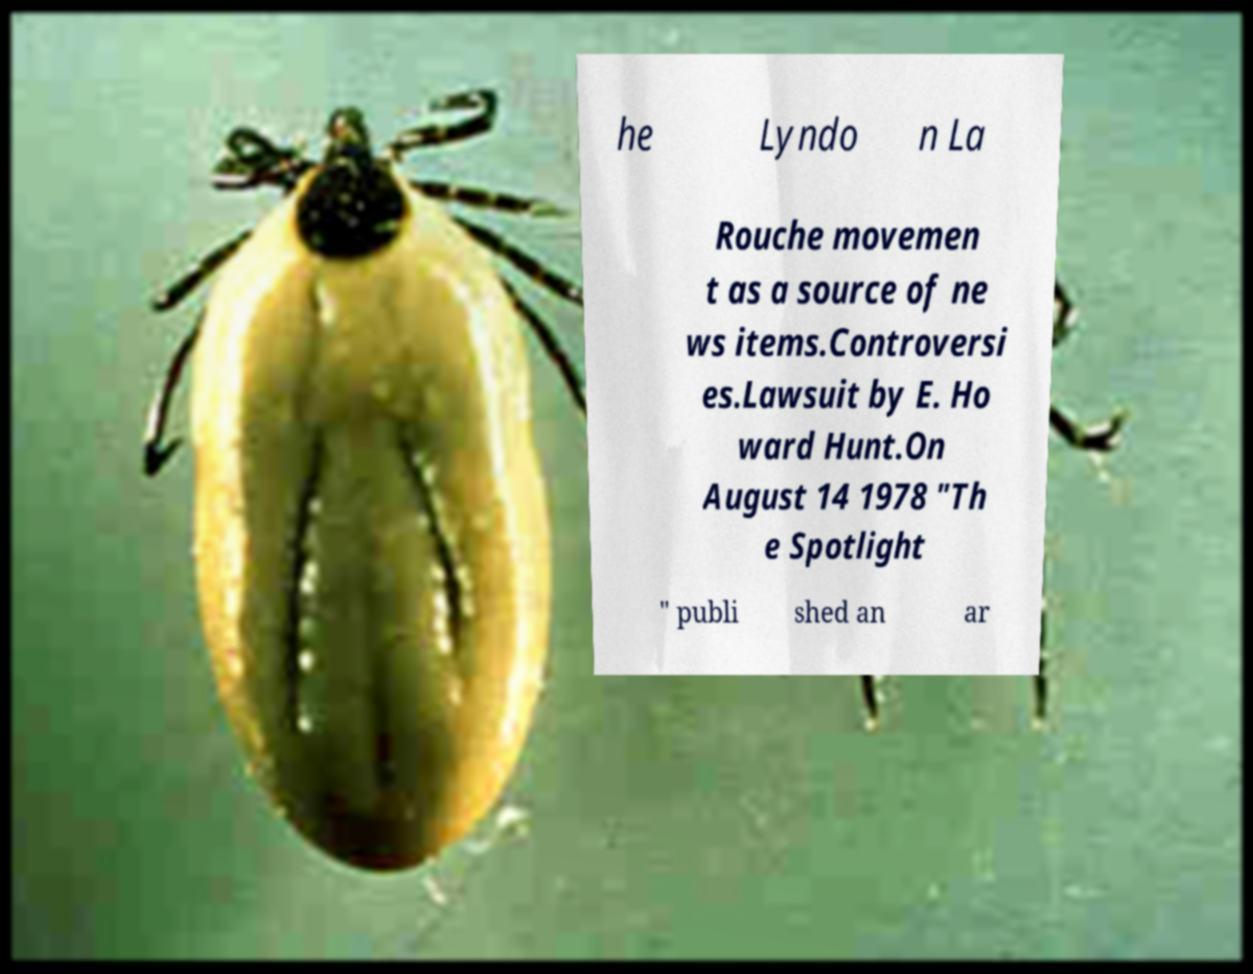Please read and relay the text visible in this image. What does it say? he Lyndo n La Rouche movemen t as a source of ne ws items.Controversi es.Lawsuit by E. Ho ward Hunt.On August 14 1978 "Th e Spotlight " publi shed an ar 